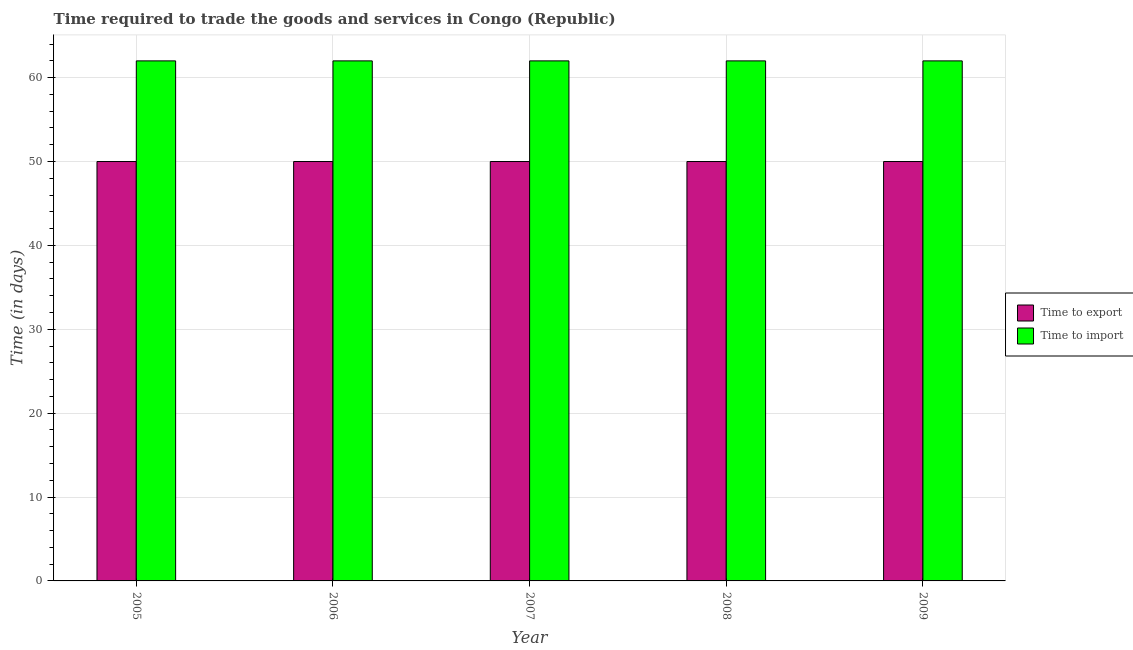How many groups of bars are there?
Make the answer very short. 5. Are the number of bars per tick equal to the number of legend labels?
Make the answer very short. Yes. How many bars are there on the 2nd tick from the right?
Your answer should be very brief. 2. What is the time to import in 2008?
Your answer should be compact. 62. Across all years, what is the maximum time to import?
Provide a short and direct response. 62. Across all years, what is the minimum time to import?
Give a very brief answer. 62. What is the total time to import in the graph?
Give a very brief answer. 310. What is the difference between the time to export in 2006 and that in 2007?
Provide a short and direct response. 0. What is the difference between the highest and the second highest time to import?
Offer a terse response. 0. What is the difference between the highest and the lowest time to import?
Give a very brief answer. 0. In how many years, is the time to export greater than the average time to export taken over all years?
Your response must be concise. 0. Is the sum of the time to import in 2005 and 2006 greater than the maximum time to export across all years?
Give a very brief answer. Yes. What does the 1st bar from the left in 2006 represents?
Your answer should be compact. Time to export. What does the 1st bar from the right in 2006 represents?
Offer a very short reply. Time to import. How many bars are there?
Provide a succinct answer. 10. What is the difference between two consecutive major ticks on the Y-axis?
Your answer should be compact. 10. Does the graph contain grids?
Your answer should be very brief. Yes. What is the title of the graph?
Provide a succinct answer. Time required to trade the goods and services in Congo (Republic). Does "Secondary" appear as one of the legend labels in the graph?
Offer a very short reply. No. What is the label or title of the Y-axis?
Keep it short and to the point. Time (in days). What is the Time (in days) of Time to export in 2005?
Your answer should be compact. 50. What is the Time (in days) in Time to import in 2008?
Give a very brief answer. 62. Across all years, what is the maximum Time (in days) of Time to import?
Offer a terse response. 62. Across all years, what is the minimum Time (in days) of Time to import?
Make the answer very short. 62. What is the total Time (in days) of Time to export in the graph?
Give a very brief answer. 250. What is the total Time (in days) of Time to import in the graph?
Offer a very short reply. 310. What is the difference between the Time (in days) in Time to export in 2005 and that in 2006?
Provide a succinct answer. 0. What is the difference between the Time (in days) in Time to import in 2005 and that in 2006?
Ensure brevity in your answer.  0. What is the difference between the Time (in days) in Time to import in 2005 and that in 2008?
Your answer should be very brief. 0. What is the difference between the Time (in days) in Time to export in 2006 and that in 2007?
Give a very brief answer. 0. What is the difference between the Time (in days) in Time to import in 2006 and that in 2008?
Provide a succinct answer. 0. What is the difference between the Time (in days) in Time to import in 2006 and that in 2009?
Make the answer very short. 0. What is the difference between the Time (in days) of Time to import in 2007 and that in 2008?
Make the answer very short. 0. What is the difference between the Time (in days) in Time to export in 2008 and that in 2009?
Give a very brief answer. 0. What is the difference between the Time (in days) in Time to import in 2008 and that in 2009?
Make the answer very short. 0. What is the difference between the Time (in days) of Time to export in 2006 and the Time (in days) of Time to import in 2009?
Ensure brevity in your answer.  -12. What is the difference between the Time (in days) in Time to export in 2007 and the Time (in days) in Time to import in 2008?
Provide a short and direct response. -12. What is the difference between the Time (in days) of Time to export in 2008 and the Time (in days) of Time to import in 2009?
Offer a terse response. -12. What is the average Time (in days) of Time to import per year?
Provide a succinct answer. 62. In the year 2005, what is the difference between the Time (in days) in Time to export and Time (in days) in Time to import?
Make the answer very short. -12. In the year 2006, what is the difference between the Time (in days) of Time to export and Time (in days) of Time to import?
Provide a succinct answer. -12. In the year 2008, what is the difference between the Time (in days) in Time to export and Time (in days) in Time to import?
Provide a succinct answer. -12. In the year 2009, what is the difference between the Time (in days) in Time to export and Time (in days) in Time to import?
Offer a terse response. -12. What is the ratio of the Time (in days) in Time to export in 2005 to that in 2007?
Ensure brevity in your answer.  1. What is the ratio of the Time (in days) in Time to import in 2005 to that in 2007?
Your answer should be very brief. 1. What is the ratio of the Time (in days) of Time to export in 2005 to that in 2008?
Keep it short and to the point. 1. What is the ratio of the Time (in days) in Time to import in 2005 to that in 2008?
Provide a succinct answer. 1. What is the ratio of the Time (in days) of Time to export in 2006 to that in 2007?
Your answer should be compact. 1. What is the ratio of the Time (in days) in Time to import in 2006 to that in 2008?
Provide a short and direct response. 1. What is the ratio of the Time (in days) of Time to import in 2006 to that in 2009?
Give a very brief answer. 1. What is the ratio of the Time (in days) in Time to import in 2007 to that in 2008?
Provide a succinct answer. 1. What is the ratio of the Time (in days) of Time to export in 2007 to that in 2009?
Provide a short and direct response. 1. What is the ratio of the Time (in days) in Time to import in 2007 to that in 2009?
Offer a terse response. 1. What is the ratio of the Time (in days) in Time to export in 2008 to that in 2009?
Offer a very short reply. 1. What is the ratio of the Time (in days) of Time to import in 2008 to that in 2009?
Make the answer very short. 1. What is the difference between the highest and the second highest Time (in days) of Time to export?
Give a very brief answer. 0. What is the difference between the highest and the lowest Time (in days) in Time to import?
Your answer should be compact. 0. 